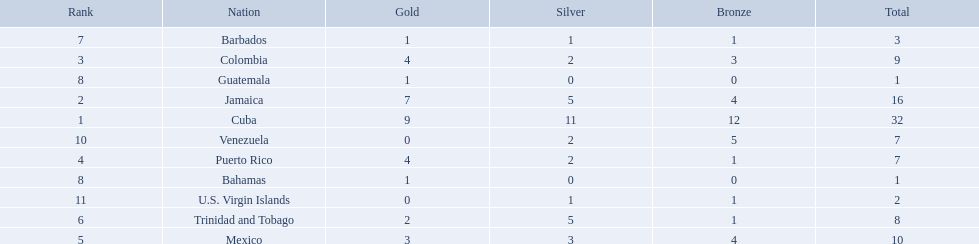What nation has won at least 4 gold medals? Cuba, Jamaica, Colombia, Puerto Rico. Of these countries who has won the least amount of bronze medals? Puerto Rico. 